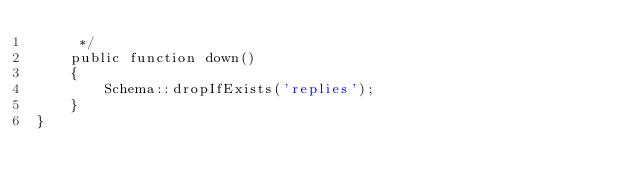Convert code to text. <code><loc_0><loc_0><loc_500><loc_500><_PHP_>     */
    public function down()
    {
        Schema::dropIfExists('replies');
    }
}
</code> 